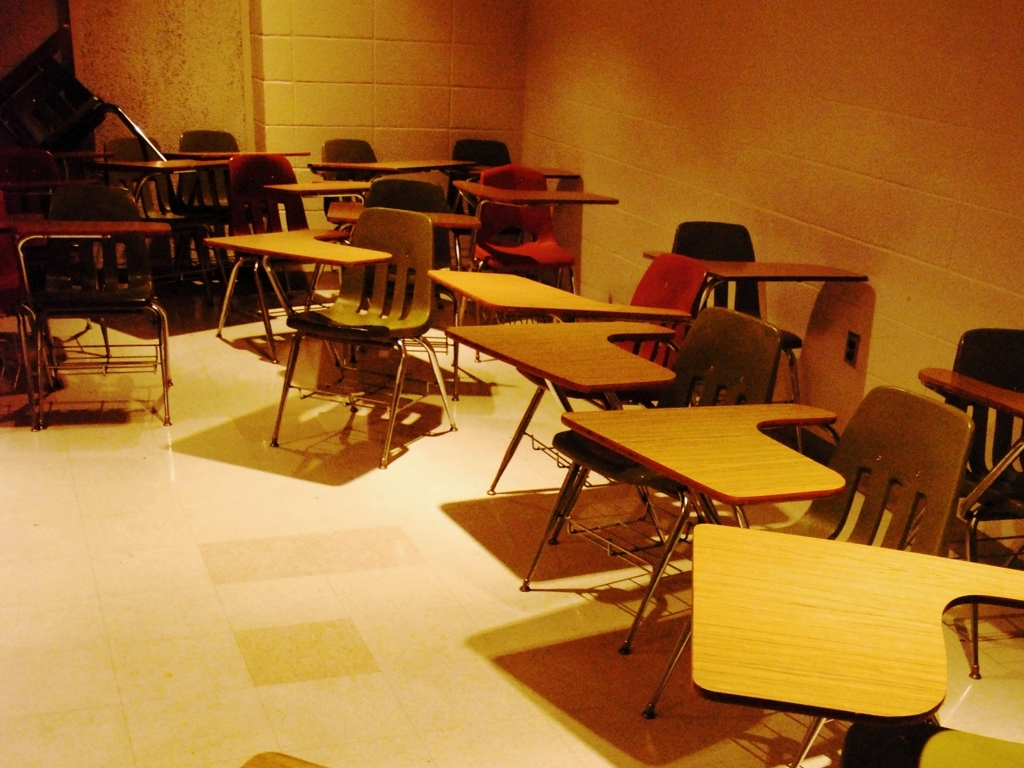Can you tell me how the arrangement of chairs and desks in this image might impact a learning environment? The arrangement of chairs and desks here seems disorganized, which could contribute to a chaotic or unfocused atmosphere. It can hinder the learning process as it may distract students and impede easy movement around the classroom. An orderly layout usually enhances concentration and facilitates interaction between students and teachers. 